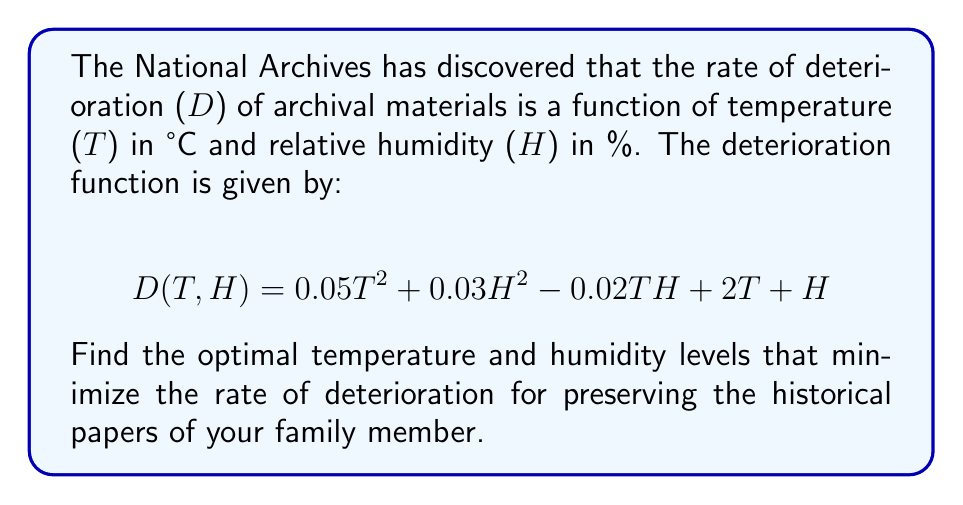Solve this math problem. To find the optimal temperature and humidity levels, we need to find the minimum point of the deterioration function D(T,H). This can be done by finding where the partial derivatives of D with respect to T and H are both zero.

Step 1: Calculate the partial derivatives
$$\frac{\partial D}{\partial T} = 0.1T - 0.02H + 2$$
$$\frac{\partial D}{\partial H} = 0.06H - 0.02T + 1$$

Step 2: Set both partial derivatives to zero and solve the system of equations
$$0.1T - 0.02H + 2 = 0 \quad (1)$$
$$0.06H - 0.02T + 1 = 0 \quad (2)$$

Step 3: Multiply equation (1) by 3 and equation (2) by 5
$$0.3T - 0.06H + 6 = 0 \quad (3)$$
$$0.3H - 0.1T + 5 = 0 \quad (4)$$

Step 4: Add equations (3) and (4)
$$0.2T + 0.24H + 11 = 0 \quad (5)$$

Step 5: Solve for H in terms of T using equation (5)
$$H = -\frac{0.2T + 11}{0.24} = -0.833T - 45.833 \quad (6)$$

Step 6: Substitute (6) into equation (1)
$$0.1T - 0.02(-0.833T - 45.833) + 2 = 0$$
$$0.1T + 0.01667T + 0.9167 + 2 = 0$$
$$0.11667T + 2.9167 = 0$$
$$T = -25$$

Step 7: Calculate H by substituting T = -25 into equation (6)
$$H = -0.833(-25) - 45.833 = 20.833 \approx 21$$

Step 8: Verify that this is a minimum point by checking the second partial derivatives
$$\frac{\partial^2 D}{\partial T^2} = 0.1 > 0$$
$$\frac{\partial^2 D}{\partial H^2} = 0.06 > 0$$
$$\frac{\partial^2 D}{\partial T \partial H} = -0.02$$

The determinant of the Hessian matrix is positive:
$$(0.1)(0.06) - (-0.02)^2 = 0.006 - 0.0004 = 0.0056 > 0$$

This confirms that the point is indeed a minimum.
Answer: Optimal temperature: -25°C, Optimal humidity: 21% 